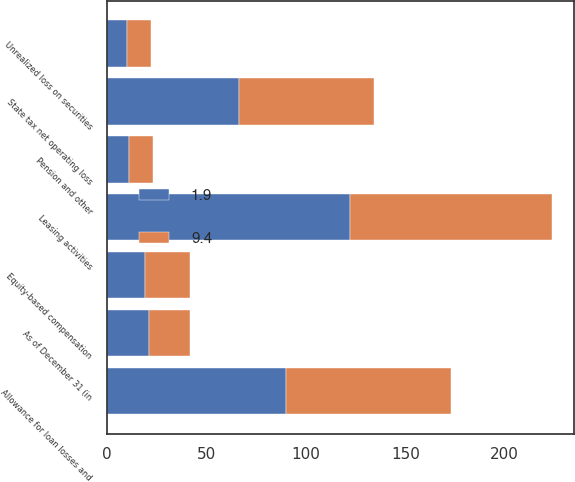Convert chart to OTSL. <chart><loc_0><loc_0><loc_500><loc_500><stacked_bar_chart><ecel><fcel>As of December 31 (in<fcel>Leasing activities<fcel>Allowance for loan losses and<fcel>State tax net operating loss<fcel>Equity-based compensation<fcel>Unrealized loss on securities<fcel>Pension and other<nl><fcel>1.9<fcel>20.95<fcel>122.2<fcel>90.2<fcel>66.3<fcel>19<fcel>10.2<fcel>10.9<nl><fcel>9.4<fcel>20.95<fcel>101.5<fcel>82.7<fcel>68<fcel>22.9<fcel>12<fcel>12.2<nl></chart> 